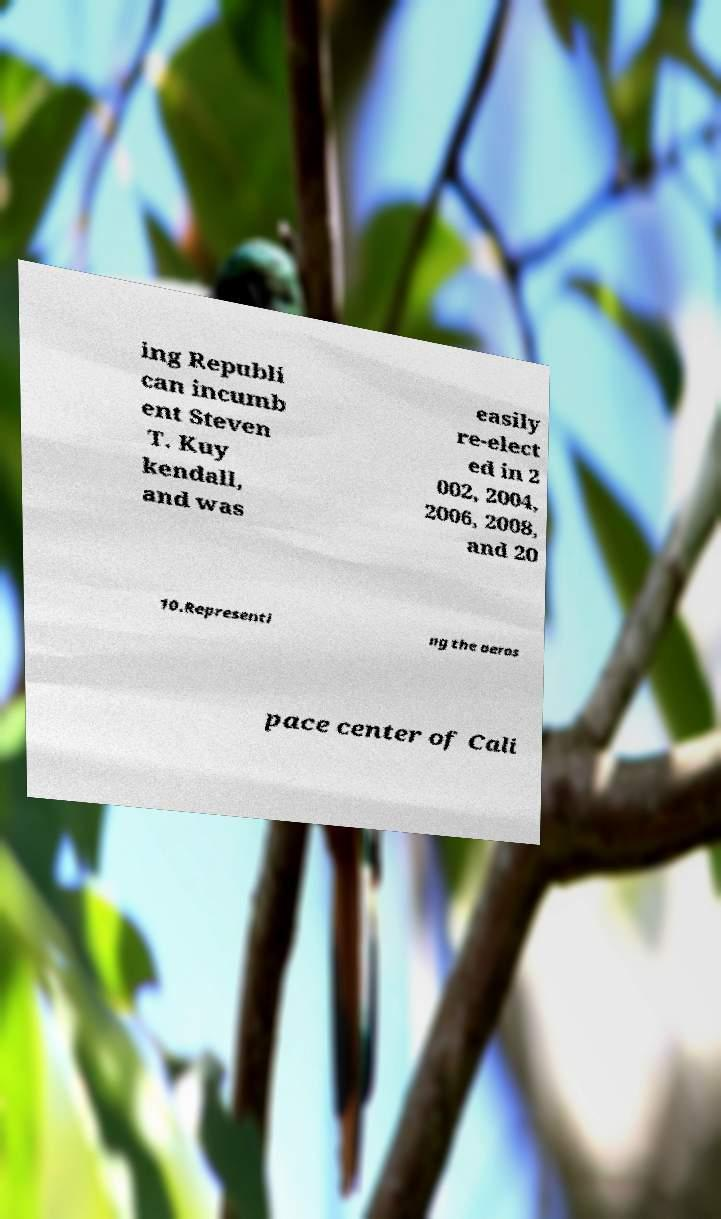What messages or text are displayed in this image? I need them in a readable, typed format. ing Republi can incumb ent Steven T. Kuy kendall, and was easily re-elect ed in 2 002, 2004, 2006, 2008, and 20 10.Representi ng the aeros pace center of Cali 